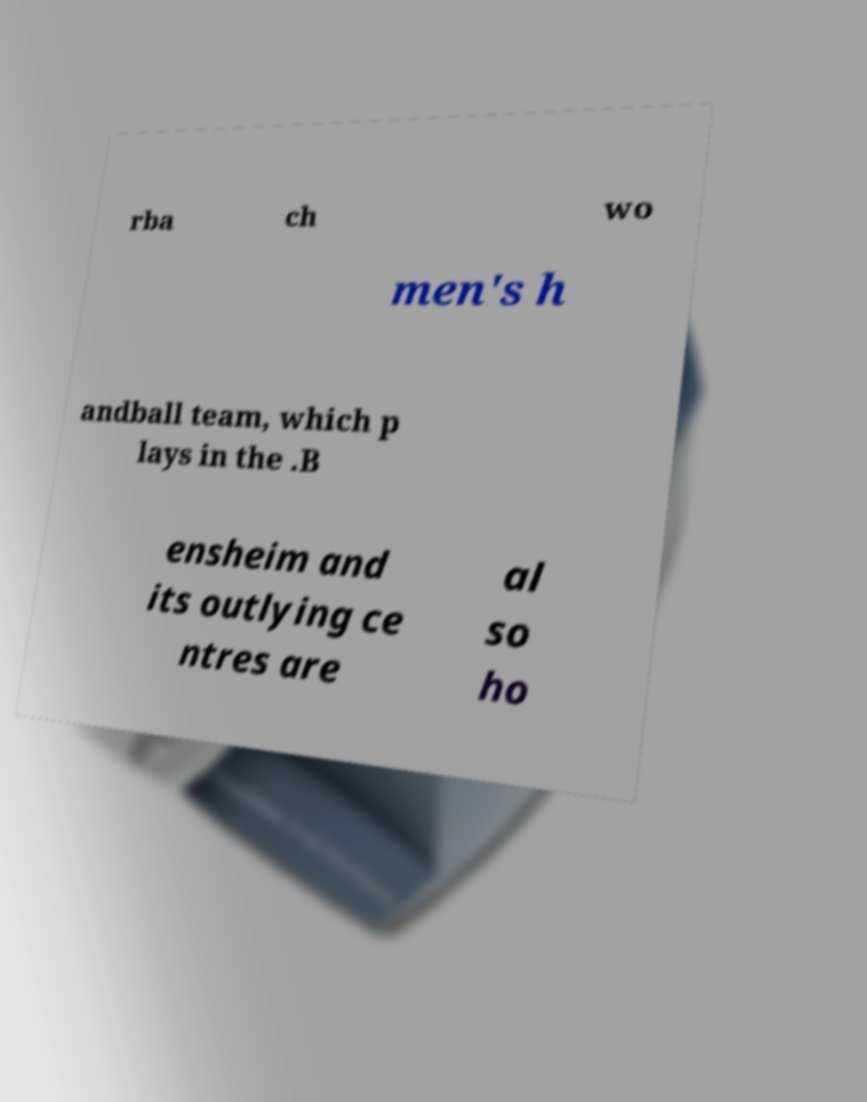Please identify and transcribe the text found in this image. rba ch wo men's h andball team, which p lays in the .B ensheim and its outlying ce ntres are al so ho 